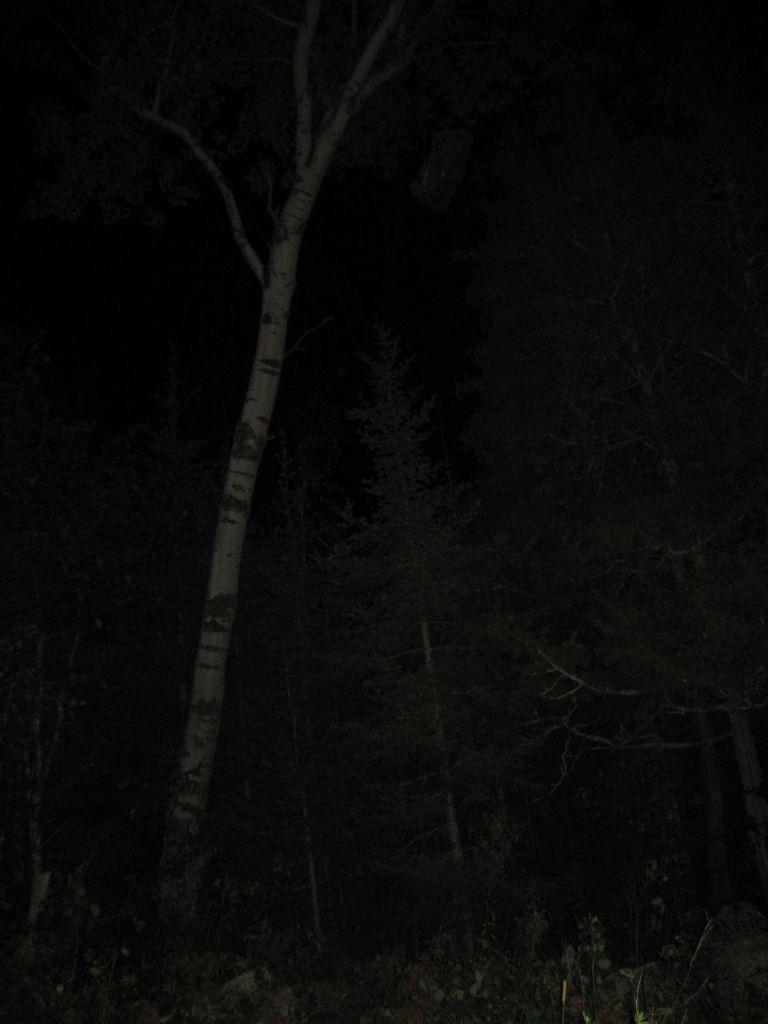What type of vegetation can be seen in the image? There are trees in the image. How would you describe the lighting in the image? The scene is dark. How many geese are visible in the image? There are no geese present in the image. Is there a car parked near the trees in the image? There is no car present in the image. Are there any chickens visible among the trees in the image? There are no chickens present in the image. 